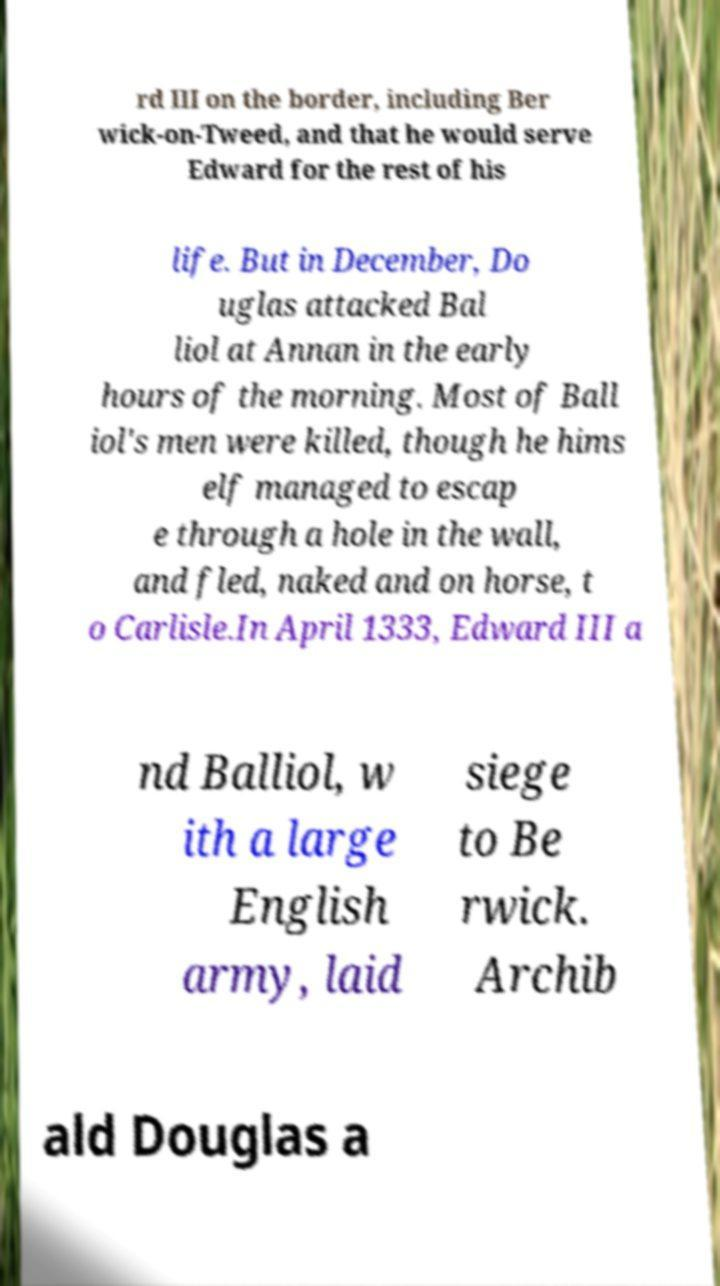Could you assist in decoding the text presented in this image and type it out clearly? rd III on the border, including Ber wick-on-Tweed, and that he would serve Edward for the rest of his life. But in December, Do uglas attacked Bal liol at Annan in the early hours of the morning. Most of Ball iol's men were killed, though he hims elf managed to escap e through a hole in the wall, and fled, naked and on horse, t o Carlisle.In April 1333, Edward III a nd Balliol, w ith a large English army, laid siege to Be rwick. Archib ald Douglas a 